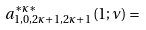<formula> <loc_0><loc_0><loc_500><loc_500>a _ { 1 , 0 , 2 \kappa + 1 , 2 \kappa + 1 } ^ { \ast \kappa \ast } ( 1 ; \nu ) =</formula> 